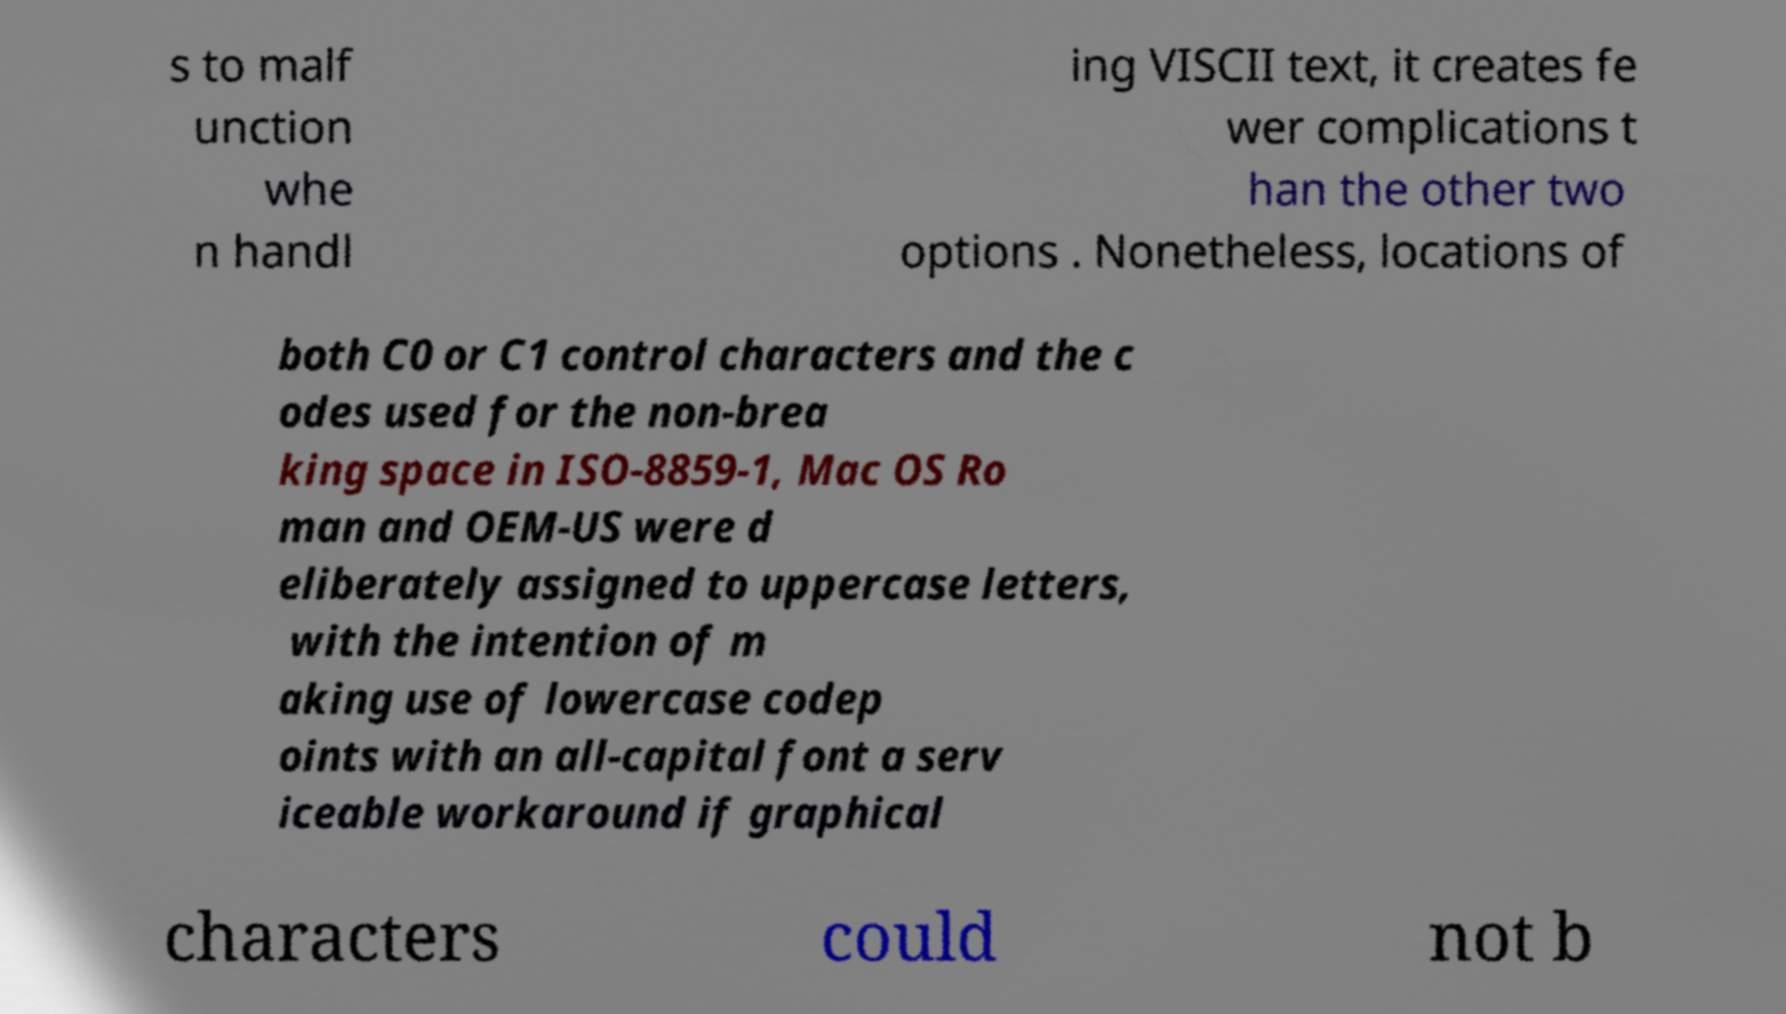Can you accurately transcribe the text from the provided image for me? s to malf unction whe n handl ing VISCII text, it creates fe wer complications t han the other two options . Nonetheless, locations of both C0 or C1 control characters and the c odes used for the non-brea king space in ISO-8859-1, Mac OS Ro man and OEM-US were d eliberately assigned to uppercase letters, with the intention of m aking use of lowercase codep oints with an all-capital font a serv iceable workaround if graphical characters could not b 